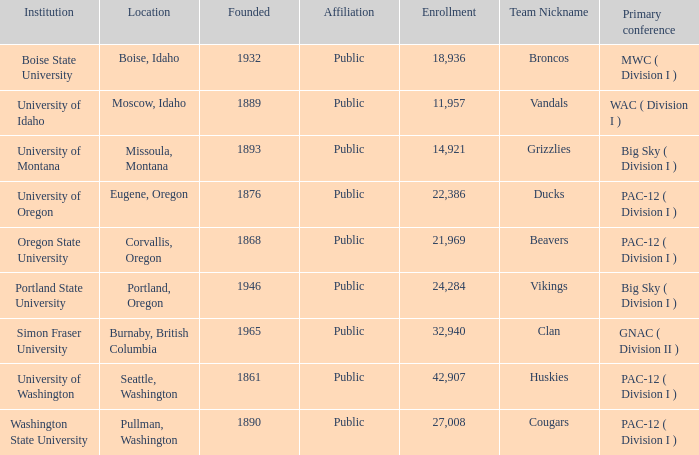Where is the team nicknamed broncos situated, having been founded after 1889? Boise, Idaho. 